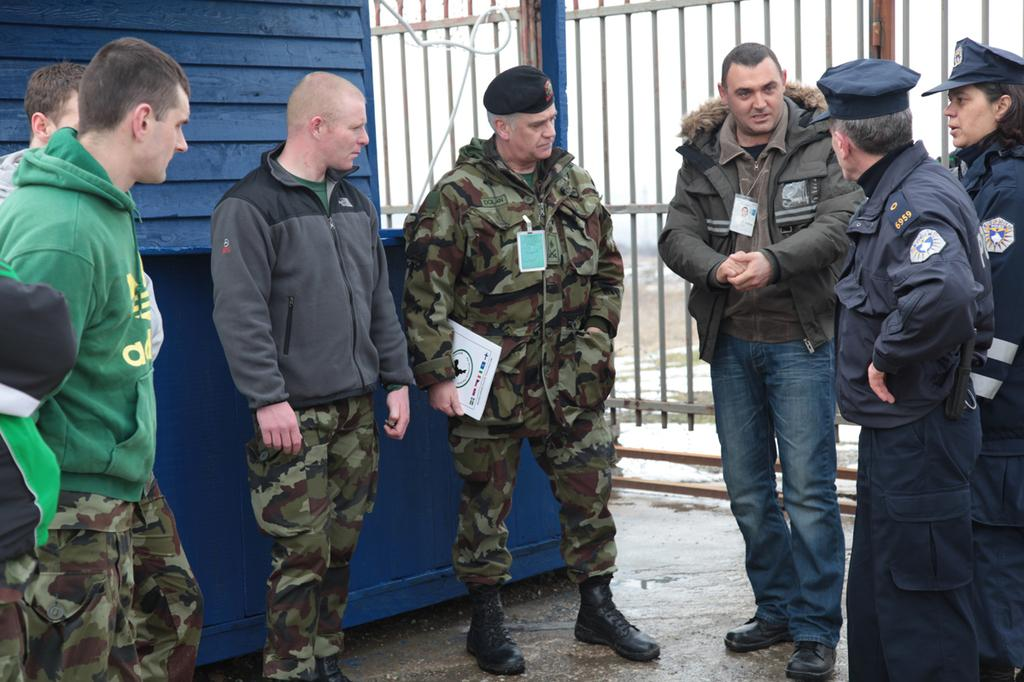How many people are in the image? There is a group of people in the image. What is one person in the group holding? One person is holding a book. What can be seen in the background of the image? There are iron grilles and a wall in the background of the image. Which toe is the person holding the book using to turn the pages? There is no indication in the image that the person holding the book is turning any pages, nor can we see their toes. 